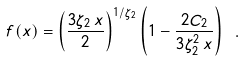Convert formula to latex. <formula><loc_0><loc_0><loc_500><loc_500>f ( x ) = \left ( \frac { 3 \zeta _ { 2 } \, x } { 2 } \right ) ^ { 1 / \zeta _ { 2 } } \left ( 1 - \frac { 2 C _ { 2 } } { 3 \zeta _ { 2 } ^ { 2 } \, x } \right ) \ .</formula> 